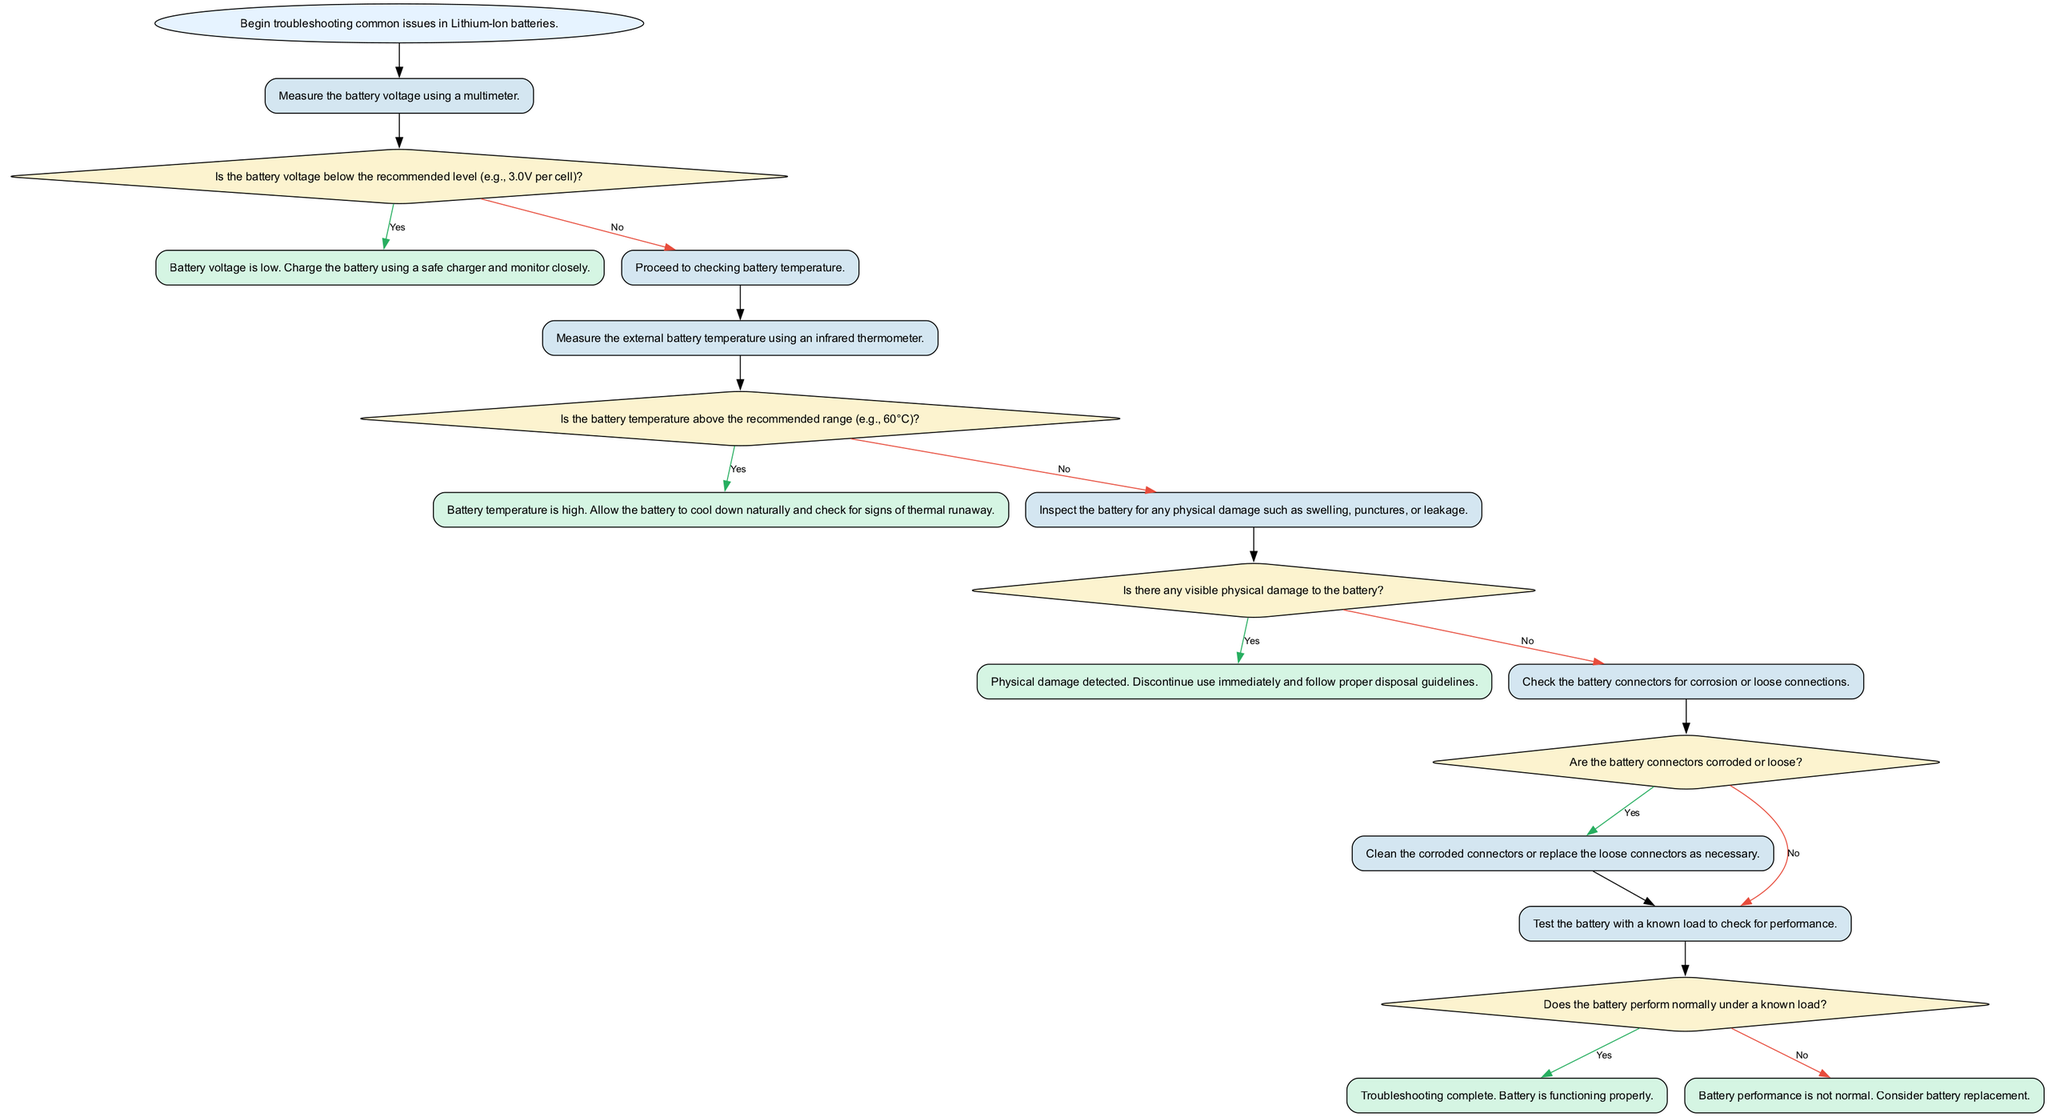What is the first step in the flowchart? The flowchart begins with the "start" node, which describes the initiation of troubleshooting common issues in Lithium-Ion batteries.
Answer: Begin troubleshooting common issues in Lithium-Ion batteries How many decision nodes are present in the diagram? There are five decision nodes in the diagram, indicated by the diamond shapes that ask if certain conditions are met.
Answer: 5 What action should be taken if the battery voltage is low? If the battery voltage is low, the flowchart instructs to charge the battery using a safe charger and monitor closely.
Answer: Charge the battery using a safe charger and monitor closely If the battery temperature is high, what should be done? The flowchart indicates that if the battery temperature is high, one should allow the battery to cool down naturally and check for signs of thermal runaway.
Answer: Allow the battery to cool down naturally and check for signs of thermal runaway What happens if physical damage to the battery is detected? If physical damage is detected, the flowchart instructs to discontinue use immediately and follow proper disposal guidelines.
Answer: Discontinue use immediately and follow proper disposal guidelines What is the next step after checking the battery connectors? After checking the battery connectors, the next step is to determine if the connectors are corroded or loose.
Answer: Are the battery connectors corroded or loose? What concludes the troubleshooting process? The troubleshooting process concludes at the "troubleshooting complete" node, indicating the battery is functioning properly.
Answer: Troubleshooting complete. Battery is functioning properly What does the flowchart suggest if the battery does not perform normally under a known load? If the battery does not perform normally, the flowchart advises considering battery replacement.
Answer: Consider battery replacement Which node indicates that the battery voltage is low? The node "voltage_below_threshold" represents the state where the battery voltage is identified as low during troubleshooting.
Answer: Battery voltage is low 